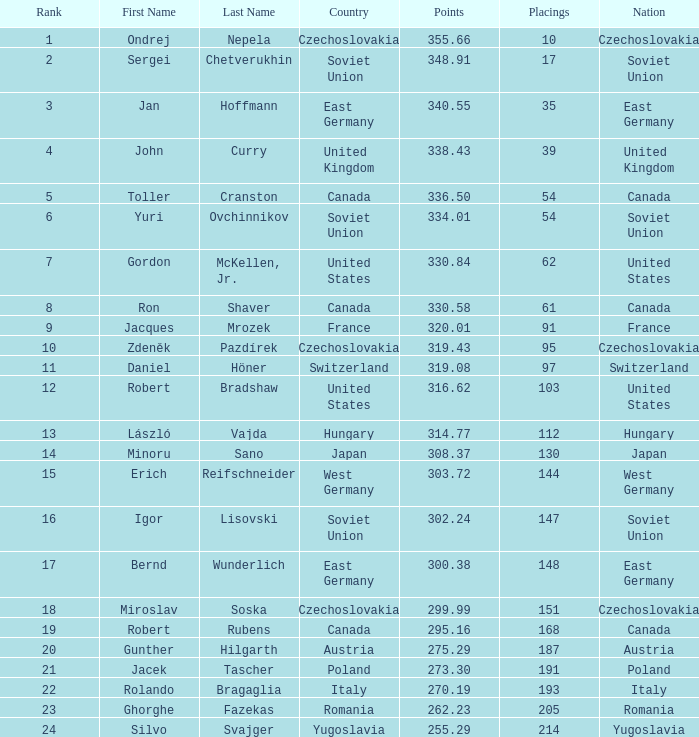Which positions have a country of west germany, and points greater than 30 None. 